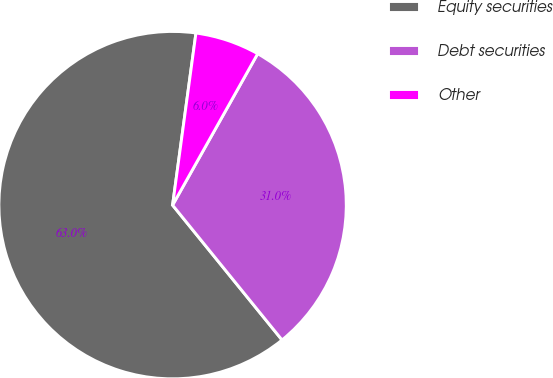Convert chart to OTSL. <chart><loc_0><loc_0><loc_500><loc_500><pie_chart><fcel>Equity securities<fcel>Debt securities<fcel>Other<nl><fcel>63.0%<fcel>31.0%<fcel>6.0%<nl></chart> 